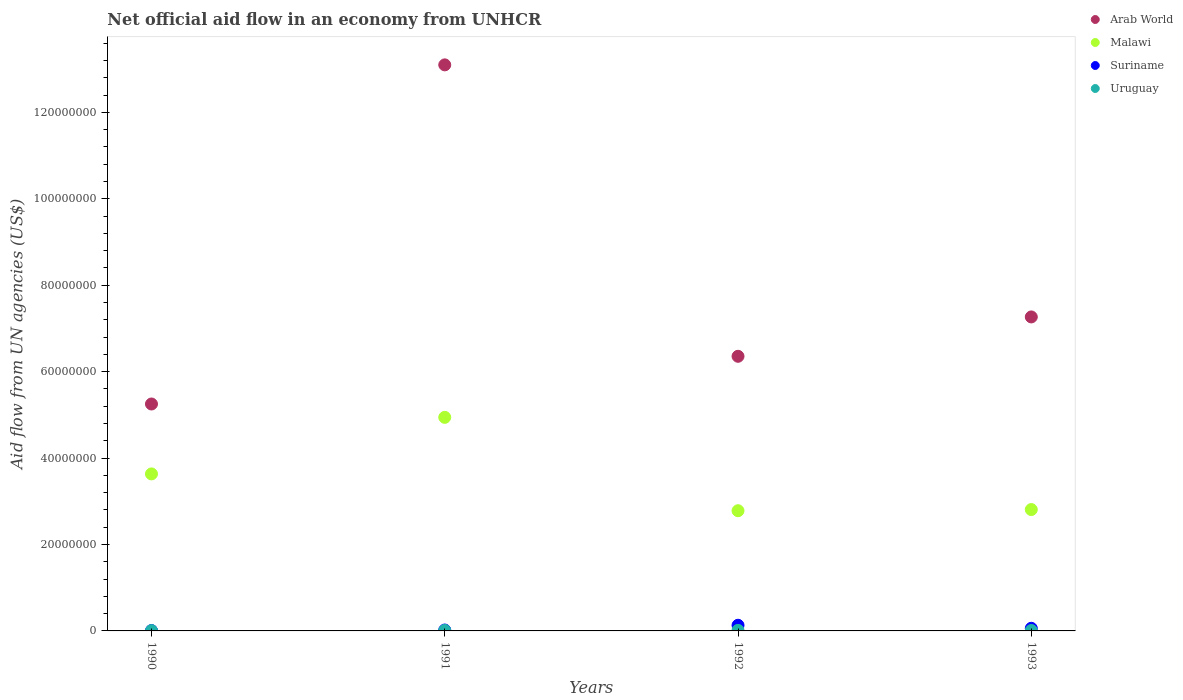How many different coloured dotlines are there?
Offer a very short reply. 4. Is the number of dotlines equal to the number of legend labels?
Make the answer very short. Yes. Across all years, what is the maximum net official aid flow in Arab World?
Keep it short and to the point. 1.31e+08. In which year was the net official aid flow in Uruguay minimum?
Ensure brevity in your answer.  1990. What is the total net official aid flow in Arab World in the graph?
Provide a short and direct response. 3.20e+08. What is the difference between the net official aid flow in Arab World in 1990 and that in 1991?
Offer a very short reply. -7.85e+07. What is the difference between the net official aid flow in Arab World in 1991 and the net official aid flow in Suriname in 1992?
Give a very brief answer. 1.30e+08. What is the average net official aid flow in Suriname per year?
Provide a succinct answer. 5.55e+05. In the year 1992, what is the difference between the net official aid flow in Arab World and net official aid flow in Malawi?
Provide a succinct answer. 3.57e+07. What is the ratio of the net official aid flow in Arab World in 1990 to that in 1991?
Offer a terse response. 0.4. What is the difference between the highest and the second highest net official aid flow in Malawi?
Offer a terse response. 1.31e+07. What is the difference between the highest and the lowest net official aid flow in Suriname?
Keep it short and to the point. 1.22e+06. In how many years, is the net official aid flow in Arab World greater than the average net official aid flow in Arab World taken over all years?
Your response must be concise. 1. Is the sum of the net official aid flow in Uruguay in 1990 and 1993 greater than the maximum net official aid flow in Suriname across all years?
Offer a very short reply. No. Is it the case that in every year, the sum of the net official aid flow in Arab World and net official aid flow in Suriname  is greater than the net official aid flow in Uruguay?
Make the answer very short. Yes. Does the net official aid flow in Suriname monotonically increase over the years?
Your response must be concise. No. Is the net official aid flow in Malawi strictly greater than the net official aid flow in Arab World over the years?
Your response must be concise. No. What is the difference between two consecutive major ticks on the Y-axis?
Offer a terse response. 2.00e+07. Does the graph contain any zero values?
Your response must be concise. No. Does the graph contain grids?
Offer a terse response. No. Where does the legend appear in the graph?
Provide a short and direct response. Top right. How are the legend labels stacked?
Ensure brevity in your answer.  Vertical. What is the title of the graph?
Your response must be concise. Net official aid flow in an economy from UNHCR. Does "France" appear as one of the legend labels in the graph?
Your response must be concise. No. What is the label or title of the X-axis?
Offer a terse response. Years. What is the label or title of the Y-axis?
Offer a terse response. Aid flow from UN agencies (US$). What is the Aid flow from UN agencies (US$) of Arab World in 1990?
Offer a very short reply. 5.25e+07. What is the Aid flow from UN agencies (US$) in Malawi in 1990?
Provide a short and direct response. 3.63e+07. What is the Aid flow from UN agencies (US$) in Uruguay in 1990?
Your response must be concise. 7.00e+04. What is the Aid flow from UN agencies (US$) in Arab World in 1991?
Your answer should be compact. 1.31e+08. What is the Aid flow from UN agencies (US$) in Malawi in 1991?
Provide a short and direct response. 4.94e+07. What is the Aid flow from UN agencies (US$) in Suriname in 1991?
Your response must be concise. 2.10e+05. What is the Aid flow from UN agencies (US$) in Arab World in 1992?
Offer a very short reply. 6.36e+07. What is the Aid flow from UN agencies (US$) in Malawi in 1992?
Keep it short and to the point. 2.78e+07. What is the Aid flow from UN agencies (US$) of Suriname in 1992?
Provide a succinct answer. 1.31e+06. What is the Aid flow from UN agencies (US$) of Arab World in 1993?
Offer a terse response. 7.27e+07. What is the Aid flow from UN agencies (US$) in Malawi in 1993?
Provide a succinct answer. 2.81e+07. What is the Aid flow from UN agencies (US$) in Suriname in 1993?
Provide a succinct answer. 6.10e+05. What is the Aid flow from UN agencies (US$) in Uruguay in 1993?
Give a very brief answer. 1.00e+05. Across all years, what is the maximum Aid flow from UN agencies (US$) in Arab World?
Give a very brief answer. 1.31e+08. Across all years, what is the maximum Aid flow from UN agencies (US$) of Malawi?
Provide a short and direct response. 4.94e+07. Across all years, what is the maximum Aid flow from UN agencies (US$) of Suriname?
Ensure brevity in your answer.  1.31e+06. Across all years, what is the minimum Aid flow from UN agencies (US$) of Arab World?
Give a very brief answer. 5.25e+07. Across all years, what is the minimum Aid flow from UN agencies (US$) in Malawi?
Offer a terse response. 2.78e+07. Across all years, what is the minimum Aid flow from UN agencies (US$) of Uruguay?
Offer a terse response. 7.00e+04. What is the total Aid flow from UN agencies (US$) in Arab World in the graph?
Offer a terse response. 3.20e+08. What is the total Aid flow from UN agencies (US$) in Malawi in the graph?
Your response must be concise. 1.42e+08. What is the total Aid flow from UN agencies (US$) of Suriname in the graph?
Offer a terse response. 2.22e+06. What is the total Aid flow from UN agencies (US$) in Uruguay in the graph?
Your answer should be compact. 4.20e+05. What is the difference between the Aid flow from UN agencies (US$) of Arab World in 1990 and that in 1991?
Provide a succinct answer. -7.85e+07. What is the difference between the Aid flow from UN agencies (US$) of Malawi in 1990 and that in 1991?
Provide a short and direct response. -1.31e+07. What is the difference between the Aid flow from UN agencies (US$) of Arab World in 1990 and that in 1992?
Your response must be concise. -1.10e+07. What is the difference between the Aid flow from UN agencies (US$) in Malawi in 1990 and that in 1992?
Your answer should be very brief. 8.52e+06. What is the difference between the Aid flow from UN agencies (US$) of Suriname in 1990 and that in 1992?
Make the answer very short. -1.22e+06. What is the difference between the Aid flow from UN agencies (US$) in Arab World in 1990 and that in 1993?
Offer a terse response. -2.02e+07. What is the difference between the Aid flow from UN agencies (US$) in Malawi in 1990 and that in 1993?
Provide a short and direct response. 8.25e+06. What is the difference between the Aid flow from UN agencies (US$) in Suriname in 1990 and that in 1993?
Your answer should be very brief. -5.20e+05. What is the difference between the Aid flow from UN agencies (US$) in Arab World in 1991 and that in 1992?
Make the answer very short. 6.74e+07. What is the difference between the Aid flow from UN agencies (US$) of Malawi in 1991 and that in 1992?
Give a very brief answer. 2.16e+07. What is the difference between the Aid flow from UN agencies (US$) in Suriname in 1991 and that in 1992?
Your answer should be very brief. -1.10e+06. What is the difference between the Aid flow from UN agencies (US$) of Uruguay in 1991 and that in 1992?
Keep it short and to the point. -10000. What is the difference between the Aid flow from UN agencies (US$) in Arab World in 1991 and that in 1993?
Ensure brevity in your answer.  5.83e+07. What is the difference between the Aid flow from UN agencies (US$) of Malawi in 1991 and that in 1993?
Ensure brevity in your answer.  2.13e+07. What is the difference between the Aid flow from UN agencies (US$) of Suriname in 1991 and that in 1993?
Your answer should be compact. -4.00e+05. What is the difference between the Aid flow from UN agencies (US$) in Arab World in 1992 and that in 1993?
Keep it short and to the point. -9.11e+06. What is the difference between the Aid flow from UN agencies (US$) in Suriname in 1992 and that in 1993?
Provide a short and direct response. 7.00e+05. What is the difference between the Aid flow from UN agencies (US$) in Uruguay in 1992 and that in 1993?
Provide a succinct answer. 3.00e+04. What is the difference between the Aid flow from UN agencies (US$) of Arab World in 1990 and the Aid flow from UN agencies (US$) of Malawi in 1991?
Give a very brief answer. 3.09e+06. What is the difference between the Aid flow from UN agencies (US$) in Arab World in 1990 and the Aid flow from UN agencies (US$) in Suriname in 1991?
Provide a succinct answer. 5.23e+07. What is the difference between the Aid flow from UN agencies (US$) of Arab World in 1990 and the Aid flow from UN agencies (US$) of Uruguay in 1991?
Ensure brevity in your answer.  5.24e+07. What is the difference between the Aid flow from UN agencies (US$) of Malawi in 1990 and the Aid flow from UN agencies (US$) of Suriname in 1991?
Provide a succinct answer. 3.61e+07. What is the difference between the Aid flow from UN agencies (US$) in Malawi in 1990 and the Aid flow from UN agencies (US$) in Uruguay in 1991?
Keep it short and to the point. 3.62e+07. What is the difference between the Aid flow from UN agencies (US$) of Arab World in 1990 and the Aid flow from UN agencies (US$) of Malawi in 1992?
Make the answer very short. 2.47e+07. What is the difference between the Aid flow from UN agencies (US$) of Arab World in 1990 and the Aid flow from UN agencies (US$) of Suriname in 1992?
Your response must be concise. 5.12e+07. What is the difference between the Aid flow from UN agencies (US$) in Arab World in 1990 and the Aid flow from UN agencies (US$) in Uruguay in 1992?
Keep it short and to the point. 5.24e+07. What is the difference between the Aid flow from UN agencies (US$) of Malawi in 1990 and the Aid flow from UN agencies (US$) of Suriname in 1992?
Ensure brevity in your answer.  3.50e+07. What is the difference between the Aid flow from UN agencies (US$) in Malawi in 1990 and the Aid flow from UN agencies (US$) in Uruguay in 1992?
Offer a very short reply. 3.62e+07. What is the difference between the Aid flow from UN agencies (US$) of Arab World in 1990 and the Aid flow from UN agencies (US$) of Malawi in 1993?
Your answer should be very brief. 2.44e+07. What is the difference between the Aid flow from UN agencies (US$) of Arab World in 1990 and the Aid flow from UN agencies (US$) of Suriname in 1993?
Offer a terse response. 5.19e+07. What is the difference between the Aid flow from UN agencies (US$) of Arab World in 1990 and the Aid flow from UN agencies (US$) of Uruguay in 1993?
Your answer should be very brief. 5.24e+07. What is the difference between the Aid flow from UN agencies (US$) in Malawi in 1990 and the Aid flow from UN agencies (US$) in Suriname in 1993?
Your response must be concise. 3.57e+07. What is the difference between the Aid flow from UN agencies (US$) in Malawi in 1990 and the Aid flow from UN agencies (US$) in Uruguay in 1993?
Your answer should be very brief. 3.62e+07. What is the difference between the Aid flow from UN agencies (US$) in Arab World in 1991 and the Aid flow from UN agencies (US$) in Malawi in 1992?
Your answer should be very brief. 1.03e+08. What is the difference between the Aid flow from UN agencies (US$) in Arab World in 1991 and the Aid flow from UN agencies (US$) in Suriname in 1992?
Your response must be concise. 1.30e+08. What is the difference between the Aid flow from UN agencies (US$) in Arab World in 1991 and the Aid flow from UN agencies (US$) in Uruguay in 1992?
Your answer should be very brief. 1.31e+08. What is the difference between the Aid flow from UN agencies (US$) in Malawi in 1991 and the Aid flow from UN agencies (US$) in Suriname in 1992?
Make the answer very short. 4.81e+07. What is the difference between the Aid flow from UN agencies (US$) of Malawi in 1991 and the Aid flow from UN agencies (US$) of Uruguay in 1992?
Your response must be concise. 4.93e+07. What is the difference between the Aid flow from UN agencies (US$) of Suriname in 1991 and the Aid flow from UN agencies (US$) of Uruguay in 1992?
Offer a very short reply. 8.00e+04. What is the difference between the Aid flow from UN agencies (US$) of Arab World in 1991 and the Aid flow from UN agencies (US$) of Malawi in 1993?
Give a very brief answer. 1.03e+08. What is the difference between the Aid flow from UN agencies (US$) in Arab World in 1991 and the Aid flow from UN agencies (US$) in Suriname in 1993?
Ensure brevity in your answer.  1.30e+08. What is the difference between the Aid flow from UN agencies (US$) in Arab World in 1991 and the Aid flow from UN agencies (US$) in Uruguay in 1993?
Your answer should be compact. 1.31e+08. What is the difference between the Aid flow from UN agencies (US$) of Malawi in 1991 and the Aid flow from UN agencies (US$) of Suriname in 1993?
Provide a succinct answer. 4.88e+07. What is the difference between the Aid flow from UN agencies (US$) of Malawi in 1991 and the Aid flow from UN agencies (US$) of Uruguay in 1993?
Offer a terse response. 4.93e+07. What is the difference between the Aid flow from UN agencies (US$) in Suriname in 1991 and the Aid flow from UN agencies (US$) in Uruguay in 1993?
Ensure brevity in your answer.  1.10e+05. What is the difference between the Aid flow from UN agencies (US$) in Arab World in 1992 and the Aid flow from UN agencies (US$) in Malawi in 1993?
Provide a succinct answer. 3.55e+07. What is the difference between the Aid flow from UN agencies (US$) of Arab World in 1992 and the Aid flow from UN agencies (US$) of Suriname in 1993?
Your answer should be very brief. 6.30e+07. What is the difference between the Aid flow from UN agencies (US$) in Arab World in 1992 and the Aid flow from UN agencies (US$) in Uruguay in 1993?
Your answer should be compact. 6.35e+07. What is the difference between the Aid flow from UN agencies (US$) in Malawi in 1992 and the Aid flow from UN agencies (US$) in Suriname in 1993?
Make the answer very short. 2.72e+07. What is the difference between the Aid flow from UN agencies (US$) of Malawi in 1992 and the Aid flow from UN agencies (US$) of Uruguay in 1993?
Make the answer very short. 2.77e+07. What is the difference between the Aid flow from UN agencies (US$) in Suriname in 1992 and the Aid flow from UN agencies (US$) in Uruguay in 1993?
Provide a succinct answer. 1.21e+06. What is the average Aid flow from UN agencies (US$) of Arab World per year?
Your answer should be compact. 7.99e+07. What is the average Aid flow from UN agencies (US$) in Malawi per year?
Ensure brevity in your answer.  3.54e+07. What is the average Aid flow from UN agencies (US$) of Suriname per year?
Give a very brief answer. 5.55e+05. What is the average Aid flow from UN agencies (US$) of Uruguay per year?
Provide a short and direct response. 1.05e+05. In the year 1990, what is the difference between the Aid flow from UN agencies (US$) in Arab World and Aid flow from UN agencies (US$) in Malawi?
Ensure brevity in your answer.  1.62e+07. In the year 1990, what is the difference between the Aid flow from UN agencies (US$) in Arab World and Aid flow from UN agencies (US$) in Suriname?
Ensure brevity in your answer.  5.24e+07. In the year 1990, what is the difference between the Aid flow from UN agencies (US$) of Arab World and Aid flow from UN agencies (US$) of Uruguay?
Your answer should be compact. 5.24e+07. In the year 1990, what is the difference between the Aid flow from UN agencies (US$) in Malawi and Aid flow from UN agencies (US$) in Suriname?
Give a very brief answer. 3.62e+07. In the year 1990, what is the difference between the Aid flow from UN agencies (US$) of Malawi and Aid flow from UN agencies (US$) of Uruguay?
Your answer should be very brief. 3.63e+07. In the year 1990, what is the difference between the Aid flow from UN agencies (US$) of Suriname and Aid flow from UN agencies (US$) of Uruguay?
Offer a terse response. 2.00e+04. In the year 1991, what is the difference between the Aid flow from UN agencies (US$) in Arab World and Aid flow from UN agencies (US$) in Malawi?
Provide a short and direct response. 8.16e+07. In the year 1991, what is the difference between the Aid flow from UN agencies (US$) of Arab World and Aid flow from UN agencies (US$) of Suriname?
Make the answer very short. 1.31e+08. In the year 1991, what is the difference between the Aid flow from UN agencies (US$) in Arab World and Aid flow from UN agencies (US$) in Uruguay?
Ensure brevity in your answer.  1.31e+08. In the year 1991, what is the difference between the Aid flow from UN agencies (US$) of Malawi and Aid flow from UN agencies (US$) of Suriname?
Make the answer very short. 4.92e+07. In the year 1991, what is the difference between the Aid flow from UN agencies (US$) in Malawi and Aid flow from UN agencies (US$) in Uruguay?
Provide a short and direct response. 4.93e+07. In the year 1992, what is the difference between the Aid flow from UN agencies (US$) in Arab World and Aid flow from UN agencies (US$) in Malawi?
Offer a terse response. 3.57e+07. In the year 1992, what is the difference between the Aid flow from UN agencies (US$) in Arab World and Aid flow from UN agencies (US$) in Suriname?
Your answer should be very brief. 6.22e+07. In the year 1992, what is the difference between the Aid flow from UN agencies (US$) of Arab World and Aid flow from UN agencies (US$) of Uruguay?
Offer a very short reply. 6.34e+07. In the year 1992, what is the difference between the Aid flow from UN agencies (US$) in Malawi and Aid flow from UN agencies (US$) in Suriname?
Offer a very short reply. 2.65e+07. In the year 1992, what is the difference between the Aid flow from UN agencies (US$) in Malawi and Aid flow from UN agencies (US$) in Uruguay?
Provide a short and direct response. 2.77e+07. In the year 1992, what is the difference between the Aid flow from UN agencies (US$) in Suriname and Aid flow from UN agencies (US$) in Uruguay?
Your response must be concise. 1.18e+06. In the year 1993, what is the difference between the Aid flow from UN agencies (US$) in Arab World and Aid flow from UN agencies (US$) in Malawi?
Ensure brevity in your answer.  4.46e+07. In the year 1993, what is the difference between the Aid flow from UN agencies (US$) in Arab World and Aid flow from UN agencies (US$) in Suriname?
Give a very brief answer. 7.21e+07. In the year 1993, what is the difference between the Aid flow from UN agencies (US$) in Arab World and Aid flow from UN agencies (US$) in Uruguay?
Keep it short and to the point. 7.26e+07. In the year 1993, what is the difference between the Aid flow from UN agencies (US$) of Malawi and Aid flow from UN agencies (US$) of Suriname?
Your answer should be very brief. 2.75e+07. In the year 1993, what is the difference between the Aid flow from UN agencies (US$) in Malawi and Aid flow from UN agencies (US$) in Uruguay?
Offer a very short reply. 2.80e+07. In the year 1993, what is the difference between the Aid flow from UN agencies (US$) of Suriname and Aid flow from UN agencies (US$) of Uruguay?
Your answer should be compact. 5.10e+05. What is the ratio of the Aid flow from UN agencies (US$) in Arab World in 1990 to that in 1991?
Keep it short and to the point. 0.4. What is the ratio of the Aid flow from UN agencies (US$) in Malawi in 1990 to that in 1991?
Offer a very short reply. 0.74. What is the ratio of the Aid flow from UN agencies (US$) in Suriname in 1990 to that in 1991?
Offer a terse response. 0.43. What is the ratio of the Aid flow from UN agencies (US$) of Uruguay in 1990 to that in 1991?
Ensure brevity in your answer.  0.58. What is the ratio of the Aid flow from UN agencies (US$) of Arab World in 1990 to that in 1992?
Make the answer very short. 0.83. What is the ratio of the Aid flow from UN agencies (US$) in Malawi in 1990 to that in 1992?
Your response must be concise. 1.31. What is the ratio of the Aid flow from UN agencies (US$) of Suriname in 1990 to that in 1992?
Your answer should be compact. 0.07. What is the ratio of the Aid flow from UN agencies (US$) in Uruguay in 1990 to that in 1992?
Ensure brevity in your answer.  0.54. What is the ratio of the Aid flow from UN agencies (US$) in Arab World in 1990 to that in 1993?
Provide a short and direct response. 0.72. What is the ratio of the Aid flow from UN agencies (US$) of Malawi in 1990 to that in 1993?
Keep it short and to the point. 1.29. What is the ratio of the Aid flow from UN agencies (US$) in Suriname in 1990 to that in 1993?
Offer a very short reply. 0.15. What is the ratio of the Aid flow from UN agencies (US$) in Uruguay in 1990 to that in 1993?
Offer a terse response. 0.7. What is the ratio of the Aid flow from UN agencies (US$) in Arab World in 1991 to that in 1992?
Give a very brief answer. 2.06. What is the ratio of the Aid flow from UN agencies (US$) of Malawi in 1991 to that in 1992?
Your response must be concise. 1.78. What is the ratio of the Aid flow from UN agencies (US$) of Suriname in 1991 to that in 1992?
Your answer should be very brief. 0.16. What is the ratio of the Aid flow from UN agencies (US$) of Arab World in 1991 to that in 1993?
Your answer should be compact. 1.8. What is the ratio of the Aid flow from UN agencies (US$) in Malawi in 1991 to that in 1993?
Offer a very short reply. 1.76. What is the ratio of the Aid flow from UN agencies (US$) in Suriname in 1991 to that in 1993?
Your answer should be compact. 0.34. What is the ratio of the Aid flow from UN agencies (US$) of Uruguay in 1991 to that in 1993?
Offer a terse response. 1.2. What is the ratio of the Aid flow from UN agencies (US$) of Arab World in 1992 to that in 1993?
Provide a succinct answer. 0.87. What is the ratio of the Aid flow from UN agencies (US$) in Malawi in 1992 to that in 1993?
Provide a succinct answer. 0.99. What is the ratio of the Aid flow from UN agencies (US$) in Suriname in 1992 to that in 1993?
Offer a very short reply. 2.15. What is the difference between the highest and the second highest Aid flow from UN agencies (US$) in Arab World?
Provide a short and direct response. 5.83e+07. What is the difference between the highest and the second highest Aid flow from UN agencies (US$) of Malawi?
Provide a short and direct response. 1.31e+07. What is the difference between the highest and the second highest Aid flow from UN agencies (US$) of Suriname?
Your response must be concise. 7.00e+05. What is the difference between the highest and the second highest Aid flow from UN agencies (US$) in Uruguay?
Keep it short and to the point. 10000. What is the difference between the highest and the lowest Aid flow from UN agencies (US$) of Arab World?
Offer a terse response. 7.85e+07. What is the difference between the highest and the lowest Aid flow from UN agencies (US$) in Malawi?
Provide a short and direct response. 2.16e+07. What is the difference between the highest and the lowest Aid flow from UN agencies (US$) in Suriname?
Keep it short and to the point. 1.22e+06. 